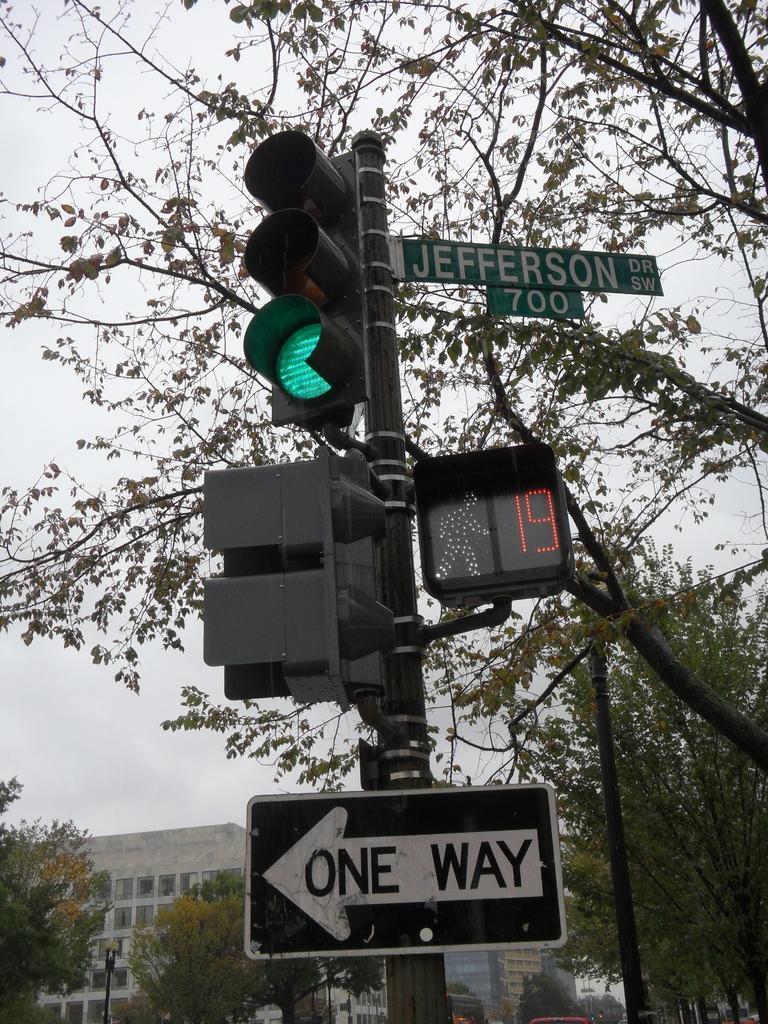Could you give a brief overview of what you see in this image? In this picture there is a traffic pole in the foreground. There are lights and boards on the pole, there is text on the boards. At the back there are buildings and trees and there are poles. At the top there is sky. 